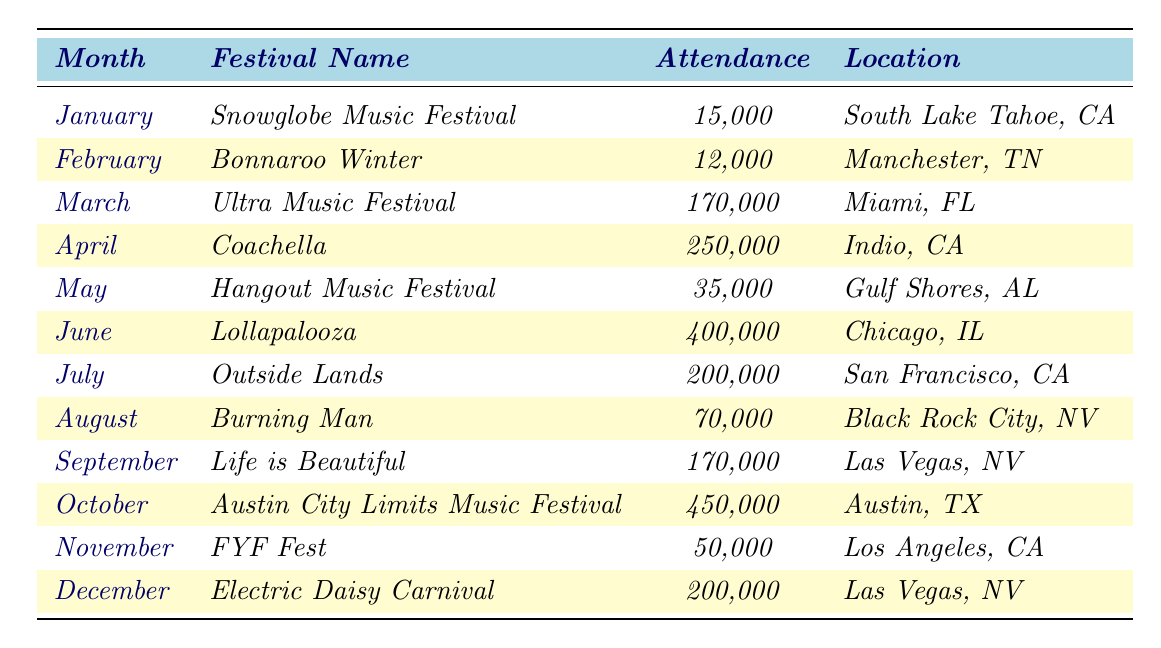What festival had the highest attendance in 2023? By reviewing the attendance figures in the table, I can see that the festival with the highest attendance is the Austin City Limits Music Festival with 450,000 attendees.
Answer: 450,000 What was the attendance at Lollapalooza? The table indicates that Lollapalooza had an attendance of 400,000 in 2023.
Answer: 400,000 Which month had the lowest festival attendance? Looking at the monthly attendance figures, February had the lowest attendance with 12,000 at Bonnaroo Winter.
Answer: 12,000 What is the total attendance across all festivals in June and July? Summing the attendance for June (400,000) and July (200,000) gives a total of 600,000.
Answer: 600,000 Did the festivals in California have higher attendance than the festivals in Tennessee in 2023? The sum of California's festivals (Coachella 250,000 + Outside Lands 200,000 + Electric Daisy Carnival 200,000 = 650,000) is compared to Tennessee's Bonnaroo Winter (12,000). Therefore, California had higher attendance.
Answer: Yes What is the average attendance of festivals in the first half of the year (January to June)? The total attendance for January (15,000), February (12,000), March (170,000), April (250,000), May (35,000), and June (400,000) is 882,000. Dividing that by 6 gives an average of 147,000.
Answer: 147,000 How many festivals had an attendance greater than 100,000? Checking the attendance figures, the festivals with attendees greater than 100,000 are Ultra Music Festival, Coachella, Lollapalooza, Outside Lands, Life is Beautiful, Austin City Limits, and Electric Daisy Carnival, making a total of 7 festivals.
Answer: 7 What percentage of attendees at Burning Man compared to the festival with the highest attendance? Burning Man had an attendance of 70,000 and the highest attendance (Austin City Limits) was 450,000. The percentage is calculated as (70,000 / 450,000) * 100, which is approximately 15.56%.
Answer: 15.56% Which festival had more than 50,000 but less than 100,000 attendees? Looking at the table, the festival Burning Man had an attendance of 70,000, which fits this range.
Answer: Burning Man What was the combined attendance for festivals located in Las Vegas? The festivals in Las Vegas were Life is Beautiful (170,000) and Electric Daisy Carnival (200,000). Their combined attendance is 370,000.
Answer: 370,000 